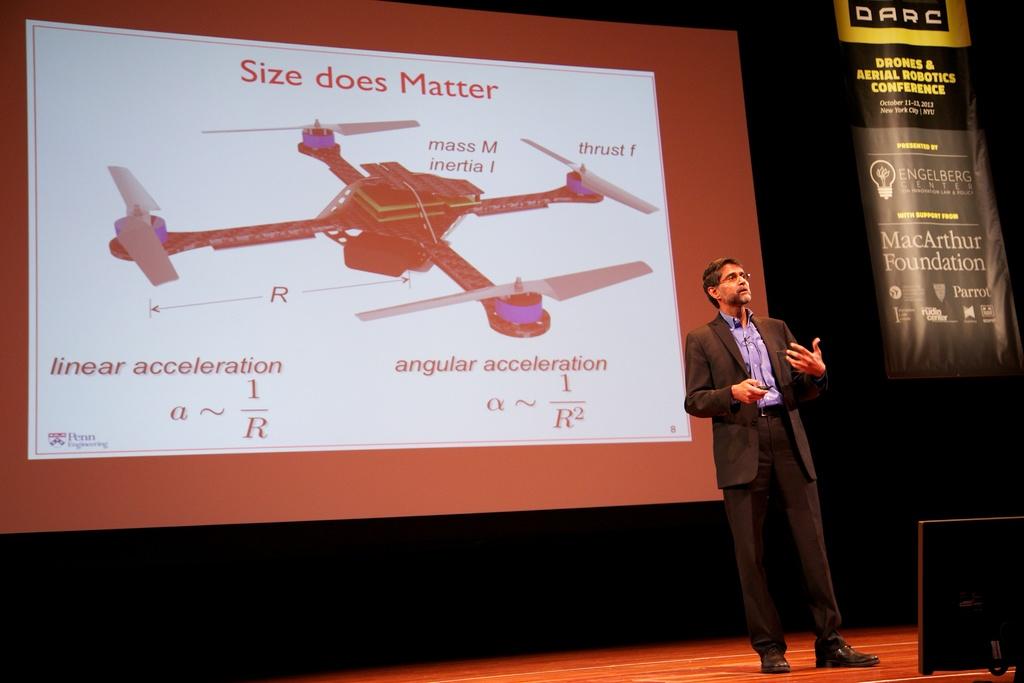What is this slide about?
Keep it short and to the point. Size does matter. What is the name of the conference?
Your response must be concise. Darc. 